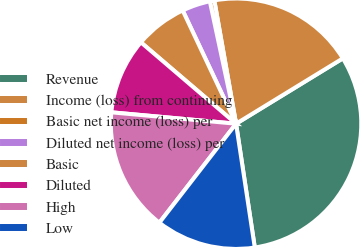Convert chart to OTSL. <chart><loc_0><loc_0><loc_500><loc_500><pie_chart><fcel>Revenue<fcel>Income (loss) from continuing<fcel>Basic net income (loss) per<fcel>Diluted net income (loss) per<fcel>Basic<fcel>Diluted<fcel>High<fcel>Low<nl><fcel>31.35%<fcel>19.04%<fcel>0.58%<fcel>3.65%<fcel>6.73%<fcel>9.81%<fcel>15.96%<fcel>12.88%<nl></chart> 